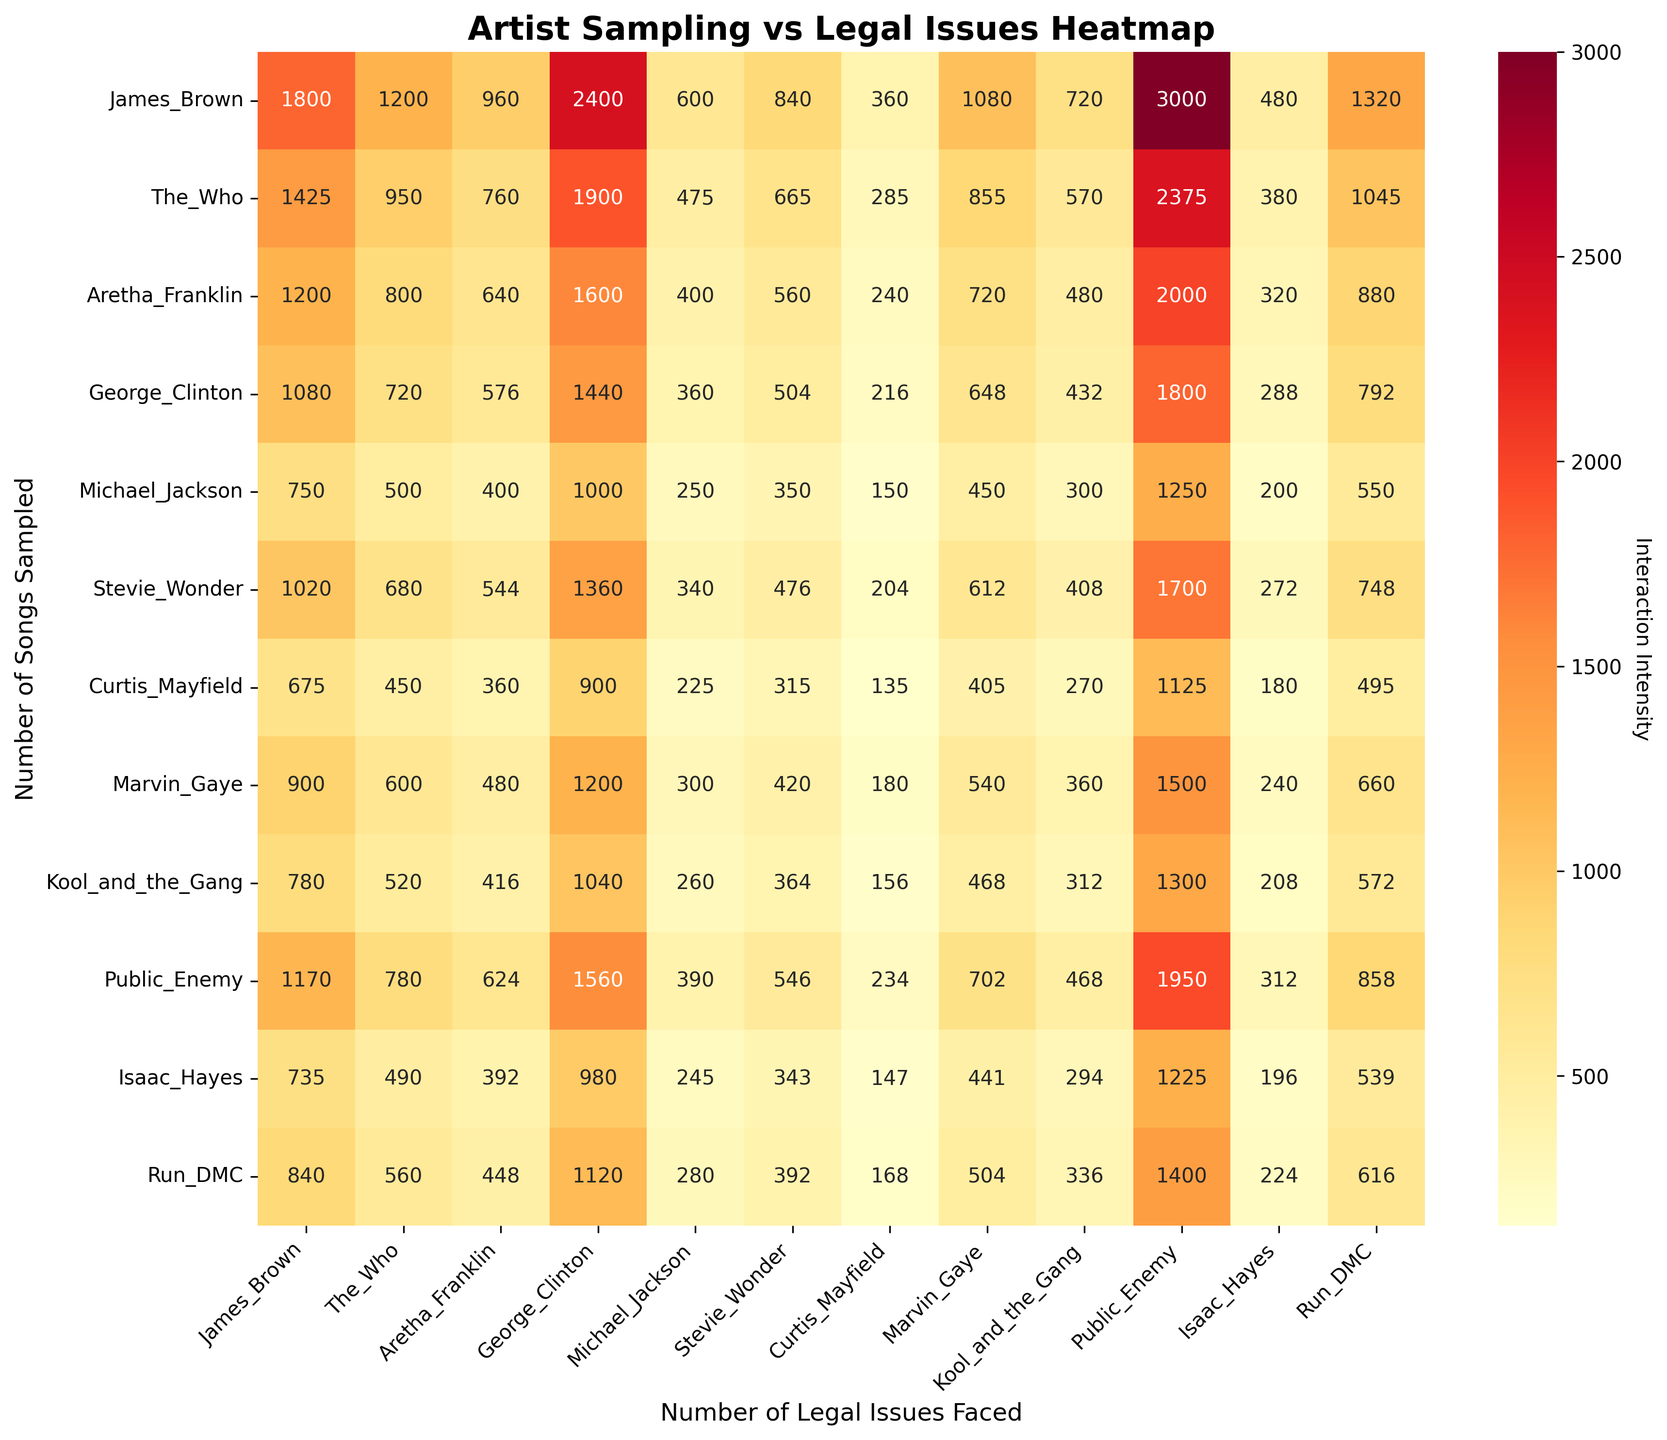What is the title of the heatmap? The title is typically displayed at the top of the heatmap. It provides a summary of what the visual represents.
Answer: Artist Sampling vs Legal Issues Heatmap Which artist has the highest number of songs sampled? Look for the artist with the highest value in the "Number of Songs Sampled" axis.
Answer: James Brown How many legal issues has Public Enemy faced? Refer to the point where Public Enemy's number of legal issues is indicated on the "Number of Legal Issues Faced" axis.
Answer: 25 What is the relationship between the number of songs sampled and the number of legal issues faced in the heatmap? The heatmap's color intensity can indicate whether there is a high or low interaction between the number of songs sampled and the number of legal issues faced.
Answer: Higher intensity suggests strong interaction Which artist's songs are sampled the least often? Identify the artist with the smallest value on the "Number of Songs Sampled" axis.
Answer: Curtis Mayfield Does George Clinton face more legal issues than Stevie Wonder? Compare the number of legal issues faced by George Clinton to those faced by Stevie Wonder on the heatmap.
Answer: Yes Who faces more legal issues than Michael Jackson but fewer than Run-DMC? Identify artists with more legal issues than Michael Jackson (5) and fewer than Run-DMC (11) by referencing the heatmap's "Number of Legal Issues Faced" axis.
Answer: Aretha Franklin, Stevie Wonder, Marvin Gaye, Isaac Hayes What was the total interaction intensity for James Brown in the heatmap? Sum all values in the row corresponding to James Brown's number of songs sampled, reflecting interactions with each artist’s legal issues count. This involves totaling the annotated values in that row.
Answer: Complex, but requires summing values in James Brown's row Comparing Public Enemy and Run-DMC, whose songs are sampled more often? Compare the values of "Number of Songs Sampled" for Public Enemy and Run-DMC.
Answer: Public Enemy How does the color intensity for Marvin Gaye compare to that of Curtis Mayfield? Observe and compare the color intensity between Marvin Gaye's and Curtis Mayfield's rows on the heatmap to understand relative interactions.
Answer: Marvin Gaye has higher intensity 